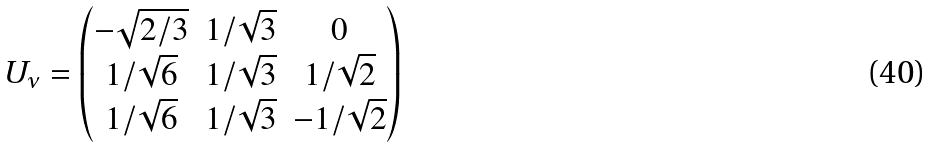Convert formula to latex. <formula><loc_0><loc_0><loc_500><loc_500>U _ { \nu } = \begin{pmatrix} - \sqrt { 2 / 3 } & 1 / \sqrt { 3 } & 0 \\ 1 / \sqrt { 6 } & 1 / \sqrt { 3 } & 1 / \sqrt { 2 } \\ 1 / \sqrt { 6 } & 1 / \sqrt { 3 } & - 1 / \sqrt { 2 } \end{pmatrix}</formula> 